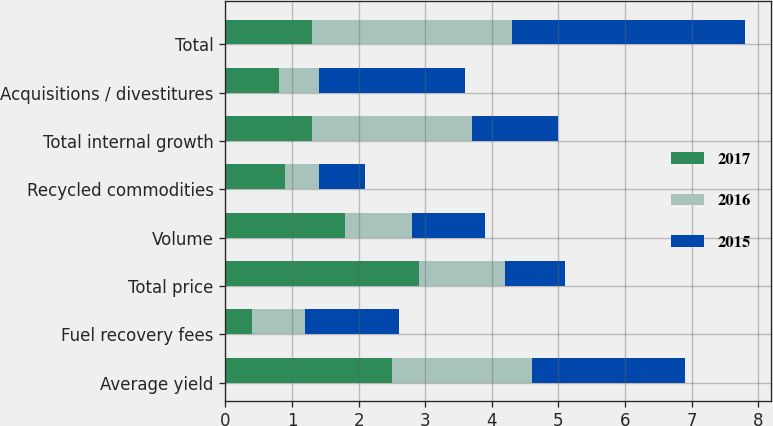Convert chart. <chart><loc_0><loc_0><loc_500><loc_500><stacked_bar_chart><ecel><fcel>Average yield<fcel>Fuel recovery fees<fcel>Total price<fcel>Volume<fcel>Recycled commodities<fcel>Total internal growth<fcel>Acquisitions / divestitures<fcel>Total<nl><fcel>2017<fcel>2.5<fcel>0.4<fcel>2.9<fcel>1.8<fcel>0.9<fcel>1.3<fcel>0.8<fcel>1.3<nl><fcel>2016<fcel>2.1<fcel>0.8<fcel>1.3<fcel>1<fcel>0.5<fcel>2.4<fcel>0.6<fcel>3<nl><fcel>2015<fcel>2.3<fcel>1.4<fcel>0.9<fcel>1.1<fcel>0.7<fcel>1.3<fcel>2.2<fcel>3.5<nl></chart> 